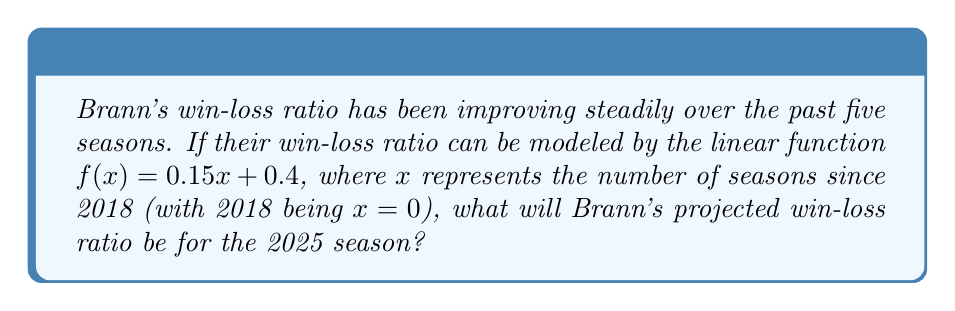Help me with this question. Let's approach this step-by-step:

1) We're given the linear function $f(x) = 0.15x + 0.4$, where:
   - $f(x)$ represents the win-loss ratio
   - $x$ represents the number of seasons since 2018
   - 0.15 is the slope (rate of improvement per season)
   - 0.4 is the y-intercept (initial win-loss ratio in 2018)

2) We need to find the win-loss ratio for 2025. Let's count the seasons:
   2018: x = 0
   2019: x = 1
   2020: x = 2
   2021: x = 3
   2022: x = 4
   2023: x = 5
   2024: x = 6
   2025: x = 7

3) So, for the 2025 season, x = 7

4) Now, let's plug x = 7 into our function:

   $f(7) = 0.15(7) + 0.4$

5) Let's calculate:
   $f(7) = 1.05 + 0.4 = 1.45$

Therefore, Brann's projected win-loss ratio for the 2025 season will be 1.45.
Answer: 1.45 